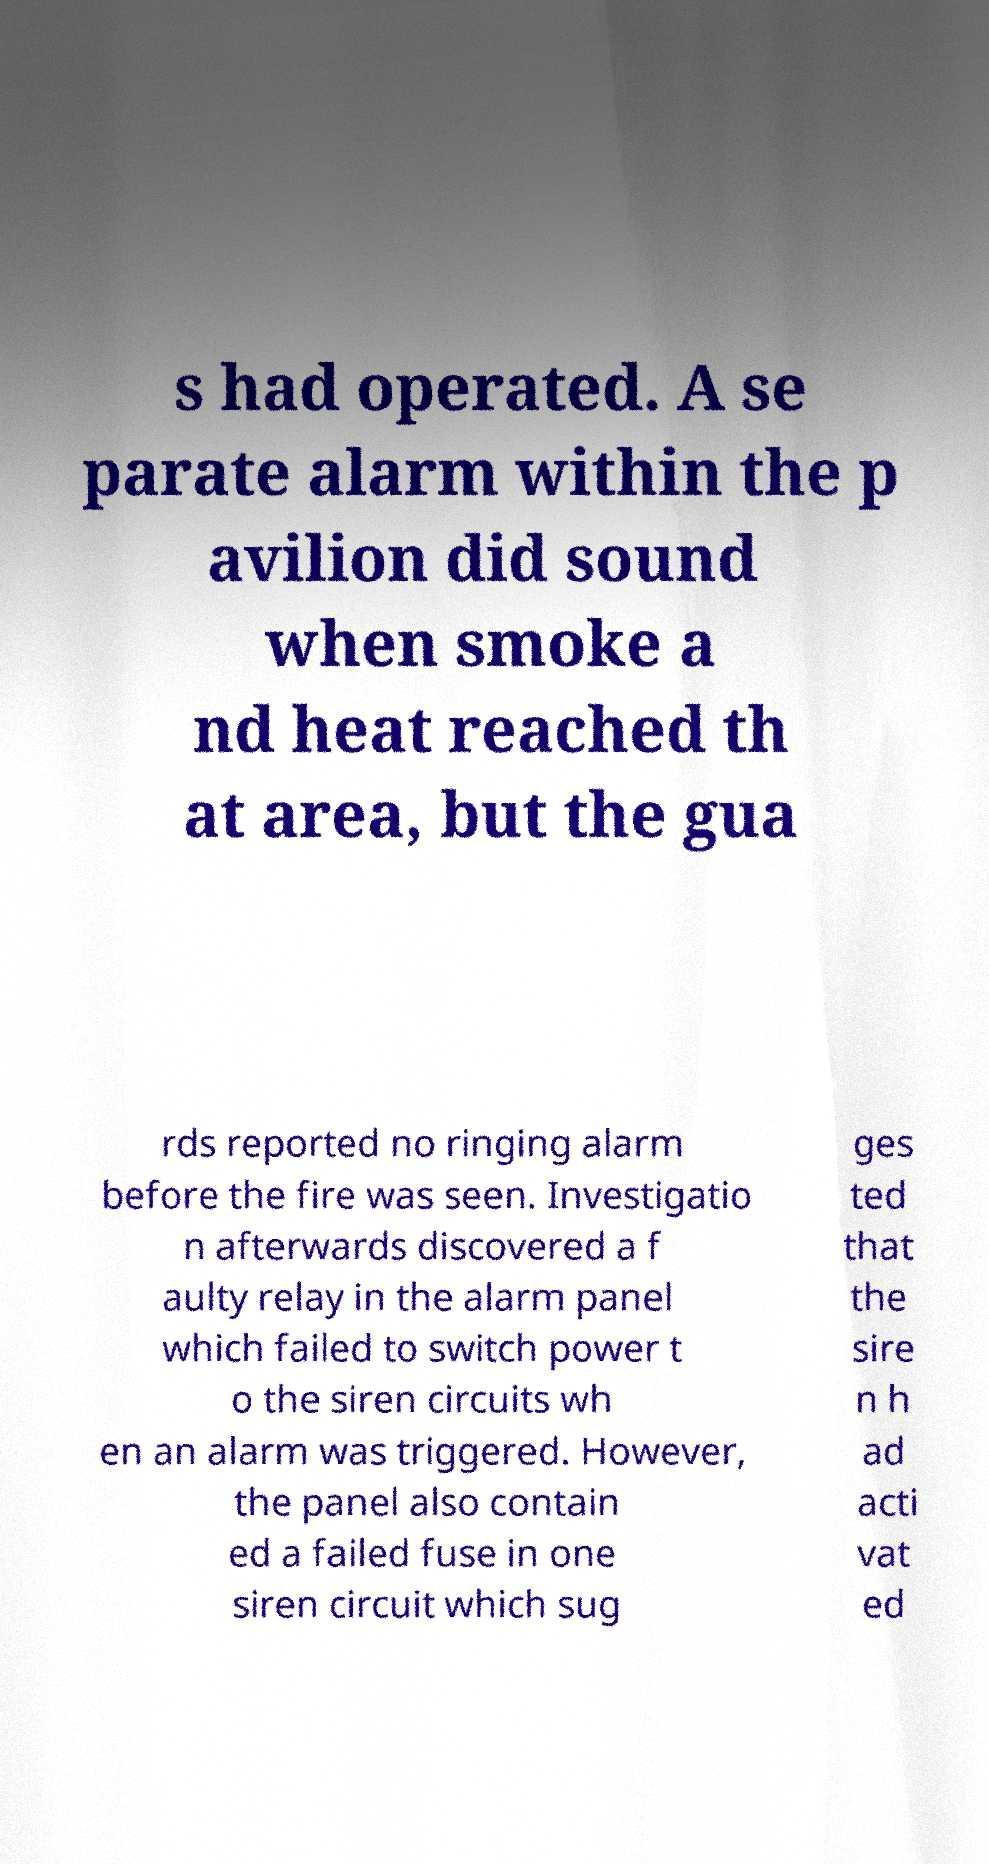Can you read and provide the text displayed in the image?This photo seems to have some interesting text. Can you extract and type it out for me? s had operated. A se parate alarm within the p avilion did sound when smoke a nd heat reached th at area, but the gua rds reported no ringing alarm before the fire was seen. Investigatio n afterwards discovered a f aulty relay in the alarm panel which failed to switch power t o the siren circuits wh en an alarm was triggered. However, the panel also contain ed a failed fuse in one siren circuit which sug ges ted that the sire n h ad acti vat ed 